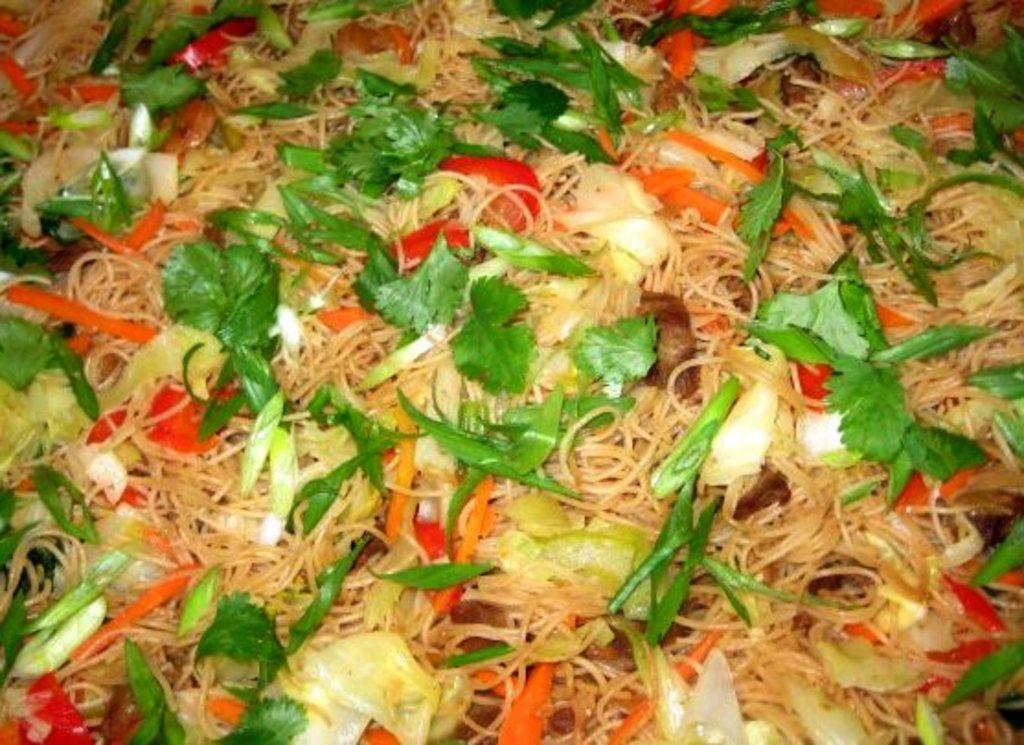How would you summarize this image in a sentence or two? In this image we can see some food containing noodles and some pieces of carrot, cabbage, beans and coriander leaves in it. 